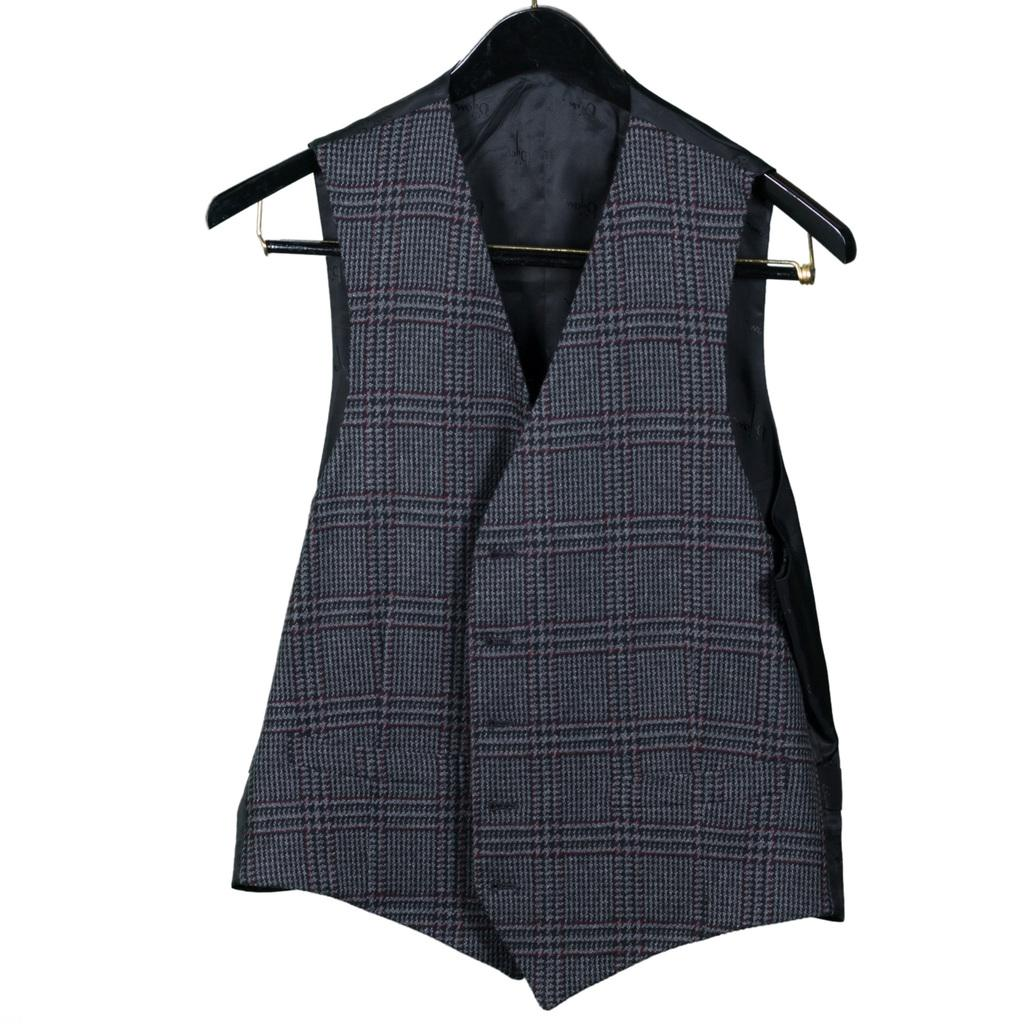What type of clothing item is in the image? There is a jacket in the image. How is the jacket positioned in the image? The jacket is on a hanger. What type of bell can be heard ringing in the image? There is no bell present in the image, and therefore no sound can be heard. 